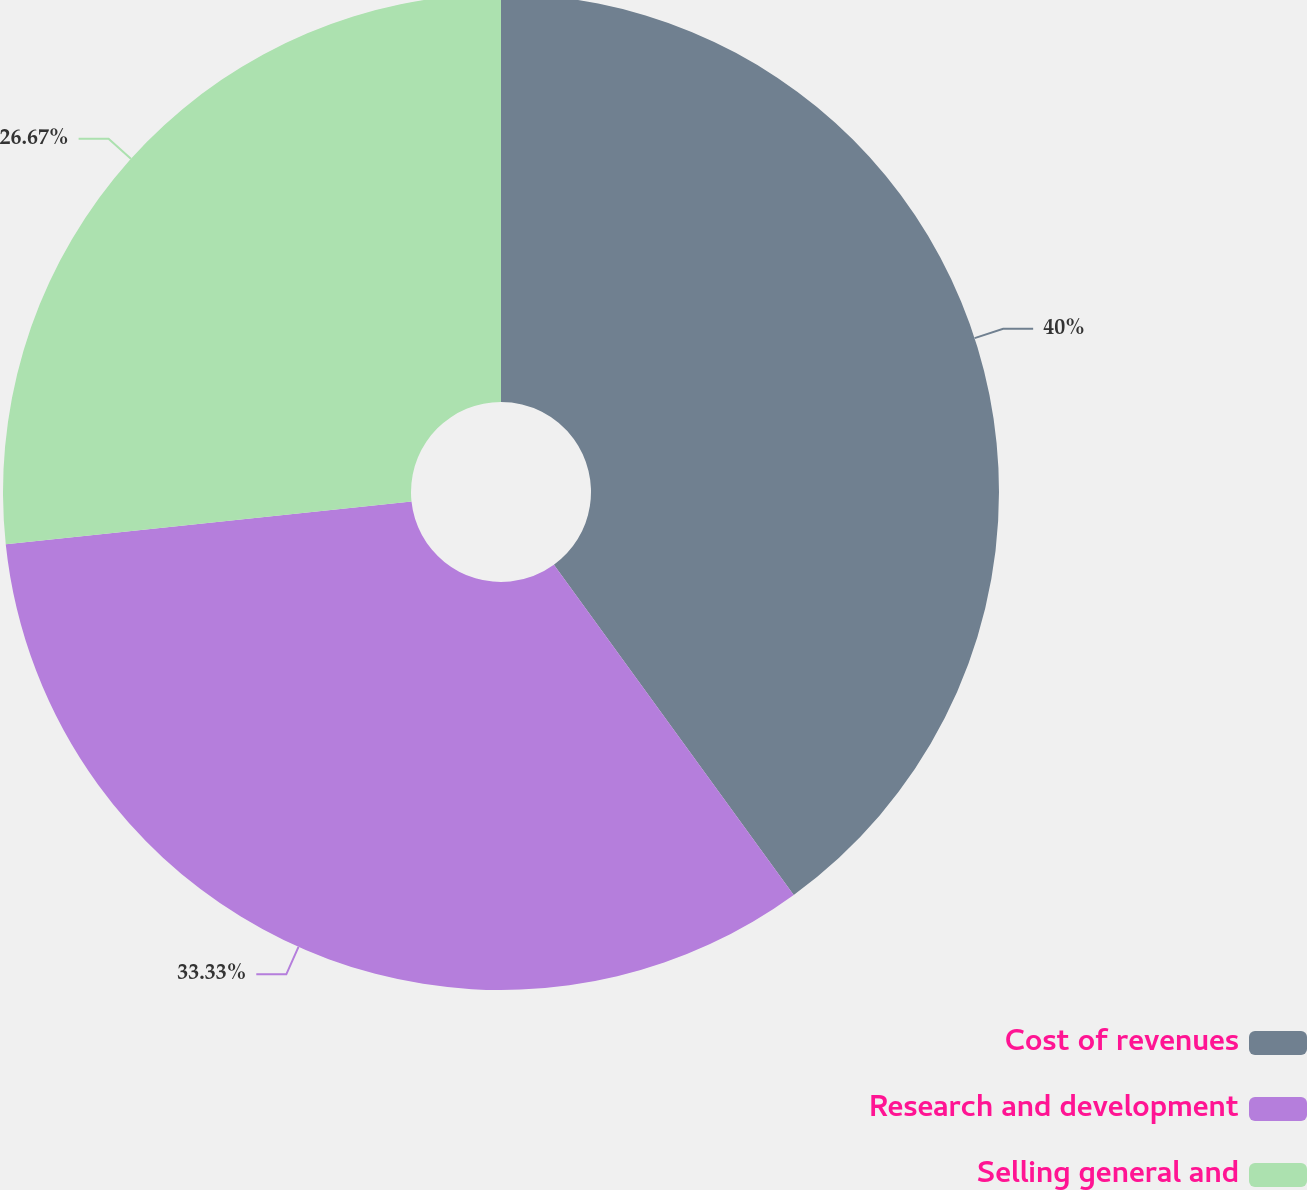<chart> <loc_0><loc_0><loc_500><loc_500><pie_chart><fcel>Cost of revenues<fcel>Research and development<fcel>Selling general and<nl><fcel>40.0%<fcel>33.33%<fcel>26.67%<nl></chart> 